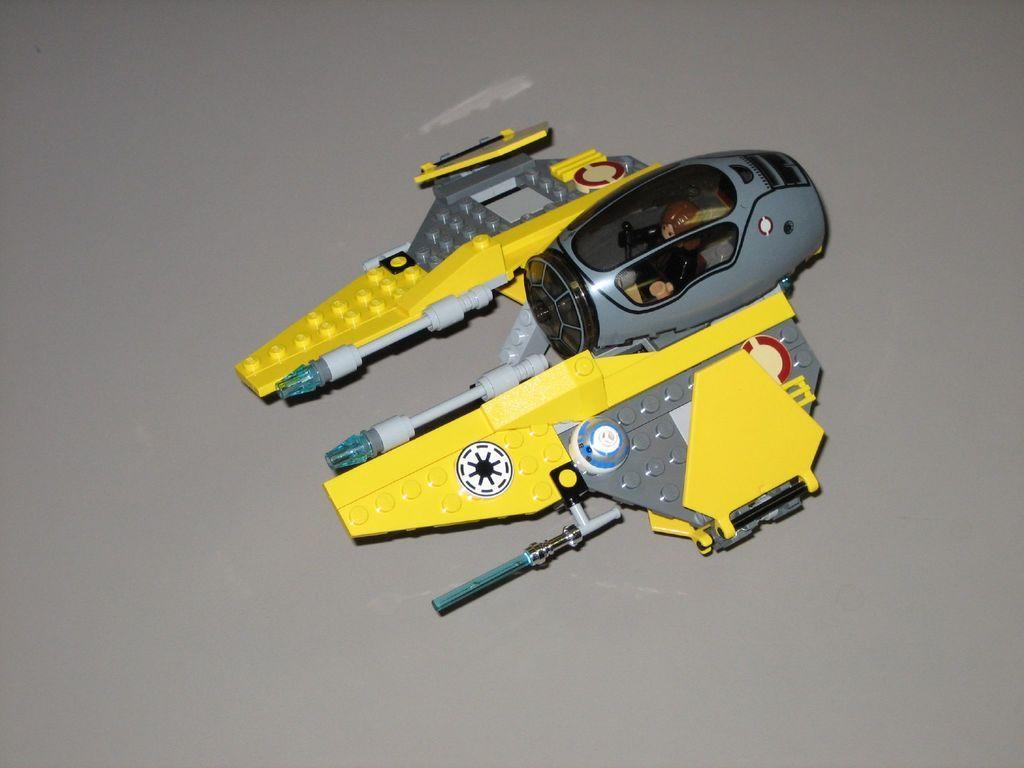How would you summarize this image in a sentence or two? In this image we can see a toy which is in yellow and ash in color and background is in ash color. 